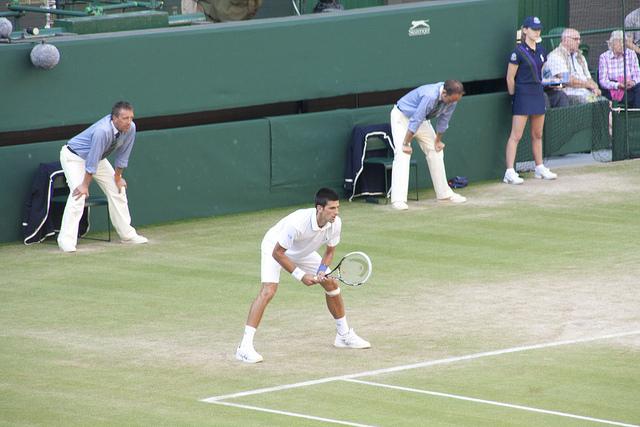What is the sport?
Answer briefly. Tennis. Is the line judge a male or female?
Be succinct. Male. Have you ever been to a tennis match?
Quick response, please. No. Why are the two men behind the player dressed exactly alike?
Answer briefly. Referees. Is the man moving forward?
Be succinct. No. 